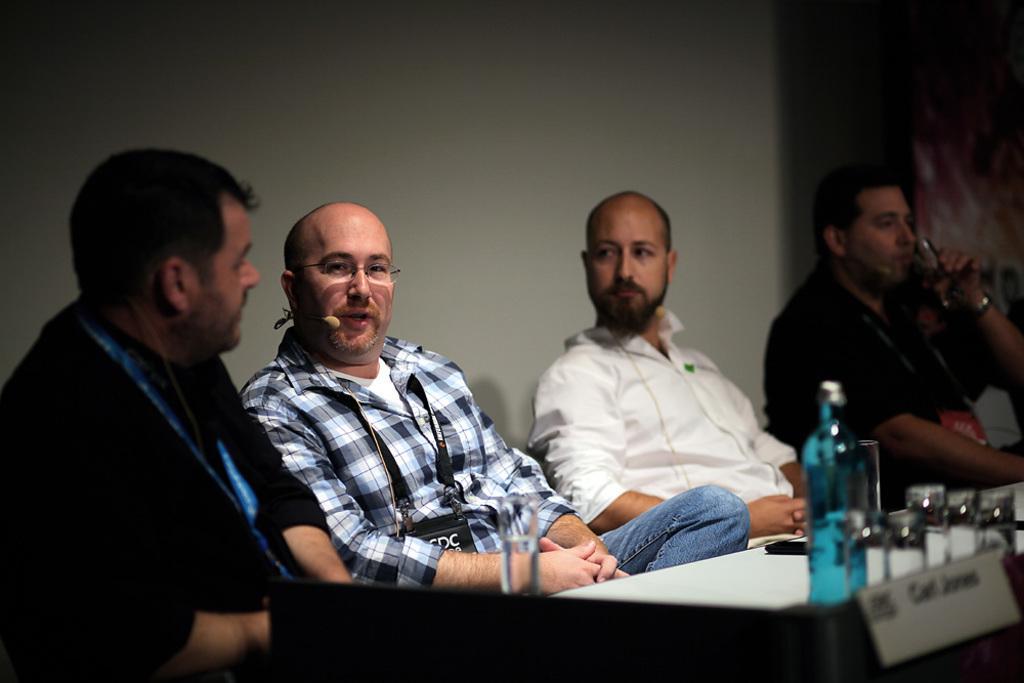How would you summarize this image in a sentence or two? This image is taken indoors. In the background there is a wall. At the bottom of the image there is a table with a name board, a bottle and a few things on it. On the left side of the image a man is sitting on the chair. In the middle of the image two men are sitting on the chairs. On the right side of the image a man is sitting on the chair and he is drinking water with a glass. 